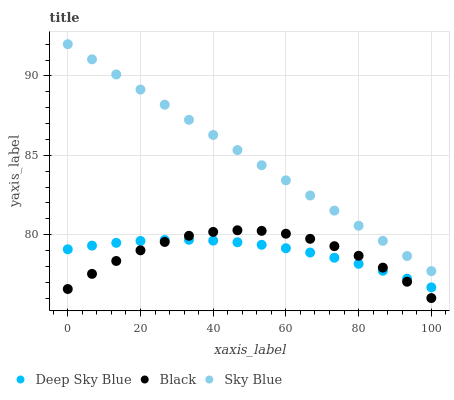Does Deep Sky Blue have the minimum area under the curve?
Answer yes or no. Yes. Does Sky Blue have the maximum area under the curve?
Answer yes or no. Yes. Does Black have the minimum area under the curve?
Answer yes or no. No. Does Black have the maximum area under the curve?
Answer yes or no. No. Is Sky Blue the smoothest?
Answer yes or no. Yes. Is Black the roughest?
Answer yes or no. Yes. Is Deep Sky Blue the smoothest?
Answer yes or no. No. Is Deep Sky Blue the roughest?
Answer yes or no. No. Does Black have the lowest value?
Answer yes or no. Yes. Does Deep Sky Blue have the lowest value?
Answer yes or no. No. Does Sky Blue have the highest value?
Answer yes or no. Yes. Does Black have the highest value?
Answer yes or no. No. Is Black less than Sky Blue?
Answer yes or no. Yes. Is Sky Blue greater than Black?
Answer yes or no. Yes. Does Black intersect Deep Sky Blue?
Answer yes or no. Yes. Is Black less than Deep Sky Blue?
Answer yes or no. No. Is Black greater than Deep Sky Blue?
Answer yes or no. No. Does Black intersect Sky Blue?
Answer yes or no. No. 